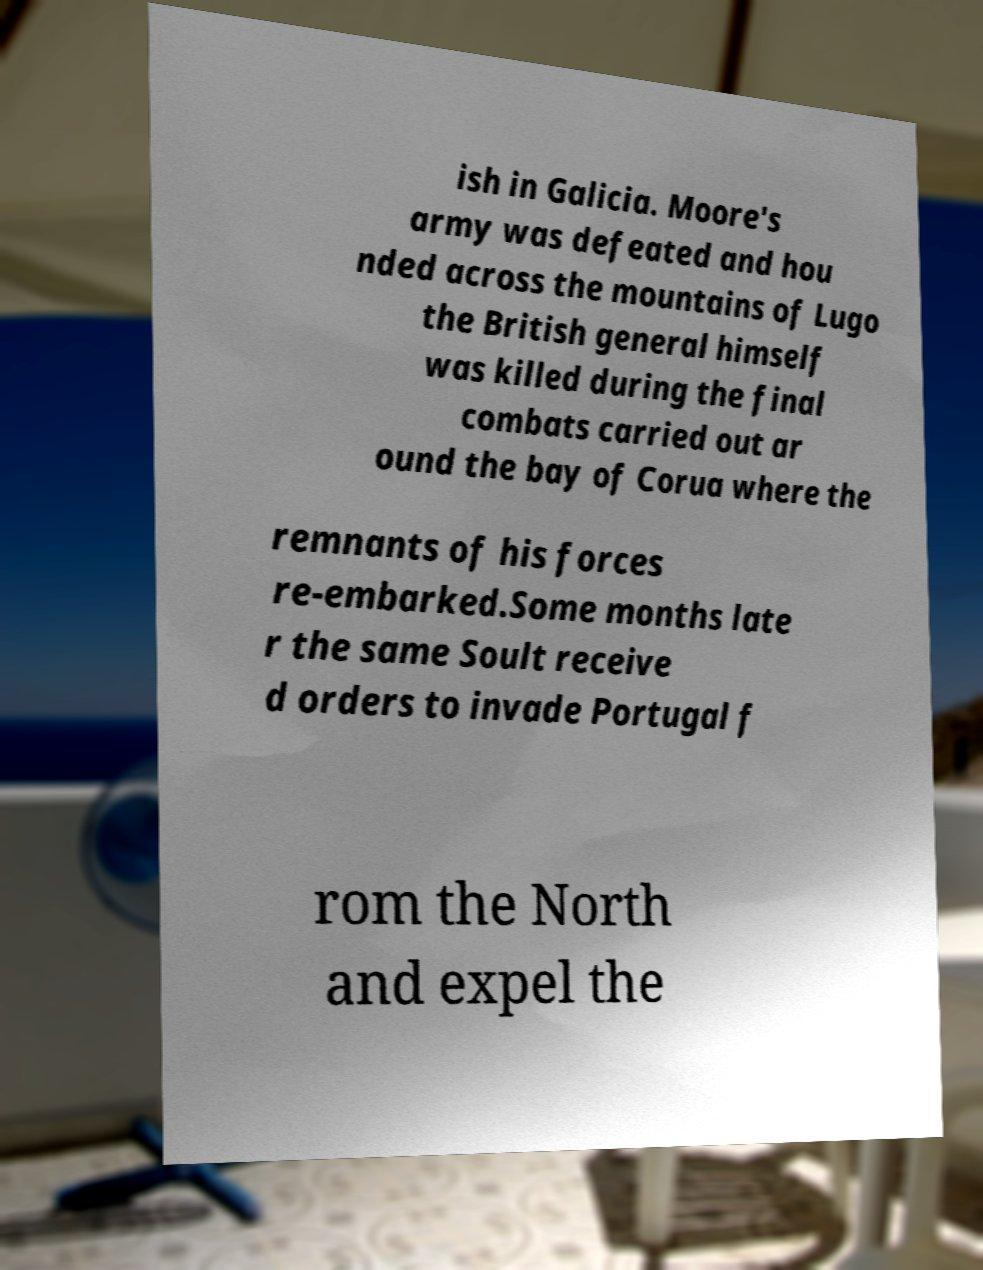Could you assist in decoding the text presented in this image and type it out clearly? ish in Galicia. Moore's army was defeated and hou nded across the mountains of Lugo the British general himself was killed during the final combats carried out ar ound the bay of Corua where the remnants of his forces re-embarked.Some months late r the same Soult receive d orders to invade Portugal f rom the North and expel the 